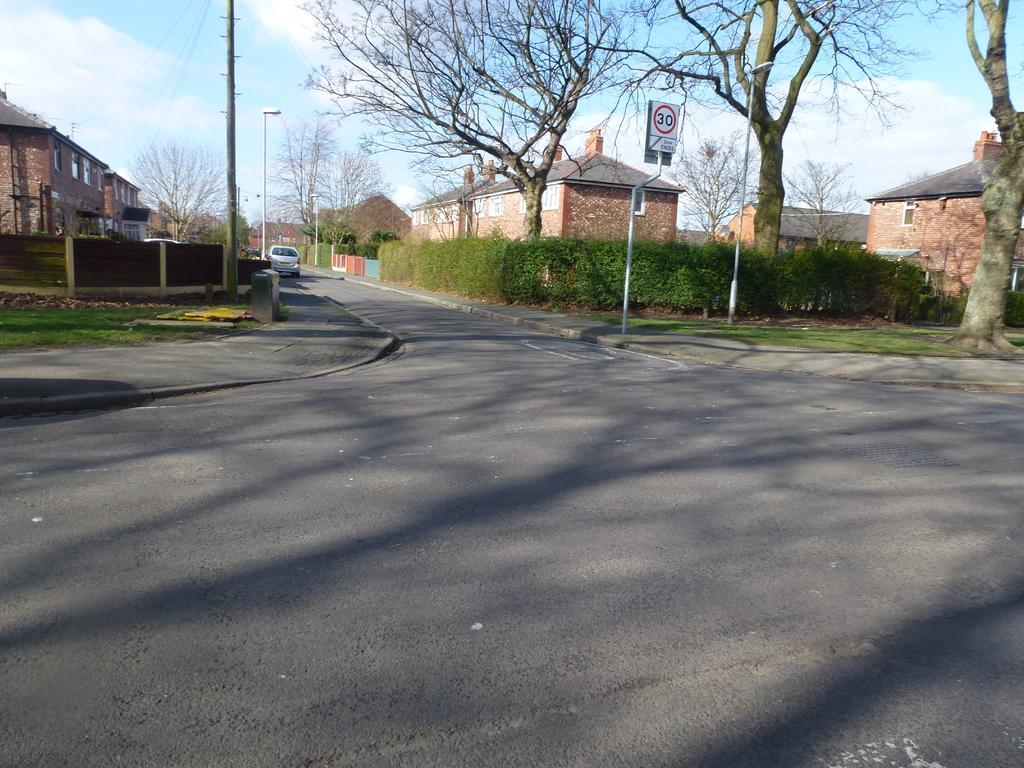What is the main feature of the image? The main feature of the image is a road. What else can be seen along the road? There is a vehicle, grass, plants, dried trees, a fence, street lights, houses, and electrical poles visible along the road. What is written on the board in the image? There is some written text on a board in the image. How many brothers are playing with the rabbits in the image? There are no brothers or rabbits present in the image. The image features a road with various objects and structures, but no living beings or animals are depicted. 